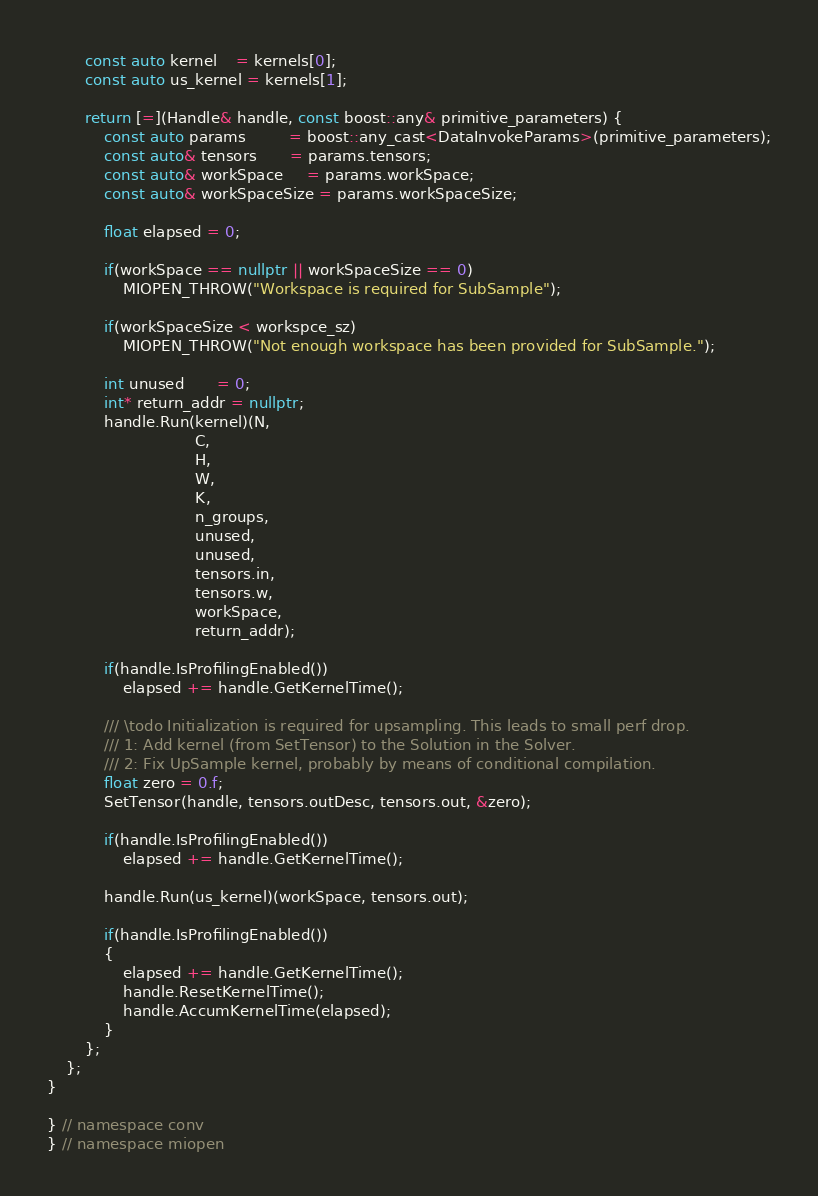<code> <loc_0><loc_0><loc_500><loc_500><_C++_>        const auto kernel    = kernels[0];
        const auto us_kernel = kernels[1];

        return [=](Handle& handle, const boost::any& primitive_parameters) {
            const auto params         = boost::any_cast<DataInvokeParams>(primitive_parameters);
            const auto& tensors       = params.tensors;
            const auto& workSpace     = params.workSpace;
            const auto& workSpaceSize = params.workSpaceSize;

            float elapsed = 0;

            if(workSpace == nullptr || workSpaceSize == 0)
                MIOPEN_THROW("Workspace is required for SubSample");

            if(workSpaceSize < workspce_sz)
                MIOPEN_THROW("Not enough workspace has been provided for SubSample.");

            int unused       = 0;
            int* return_addr = nullptr;
            handle.Run(kernel)(N,
                               C,
                               H,
                               W,
                               K,
                               n_groups,
                               unused,
                               unused,
                               tensors.in,
                               tensors.w,
                               workSpace,
                               return_addr);

            if(handle.IsProfilingEnabled())
                elapsed += handle.GetKernelTime();

            /// \todo Initialization is required for upsampling. This leads to small perf drop.
            /// 1: Add kernel (from SetTensor) to the Solution in the Solver.
            /// 2: Fix UpSample kernel, probably by means of conditional compilation.
            float zero = 0.f;
            SetTensor(handle, tensors.outDesc, tensors.out, &zero);

            if(handle.IsProfilingEnabled())
                elapsed += handle.GetKernelTime();

            handle.Run(us_kernel)(workSpace, tensors.out);

            if(handle.IsProfilingEnabled())
            {
                elapsed += handle.GetKernelTime();
                handle.ResetKernelTime();
                handle.AccumKernelTime(elapsed);
            }
        };
    };
}

} // namespace conv
} // namespace miopen
</code> 